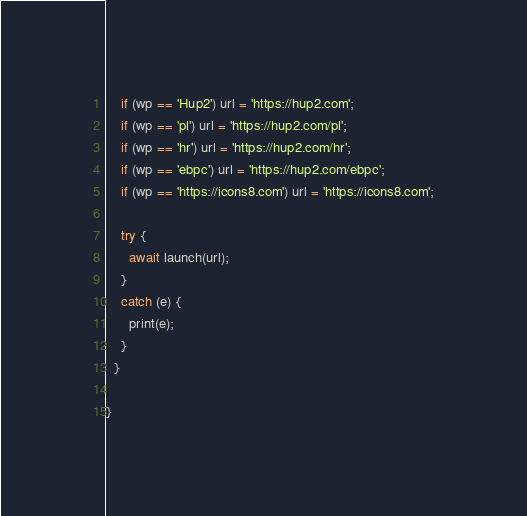Convert code to text. <code><loc_0><loc_0><loc_500><loc_500><_Dart_>
    if (wp == 'Hup2') url = 'https://hup2.com';
    if (wp == 'pl') url = 'https://hup2.com/pl';
    if (wp == 'hr') url = 'https://hup2.com/hr';
    if (wp == 'ebpc') url = 'https://hup2.com/ebpc';
    if (wp == 'https://icons8.com') url = 'https://icons8.com';

    try {
      await launch(url);
    }
    catch (e) {
      print(e);
    }
  }

}</code> 